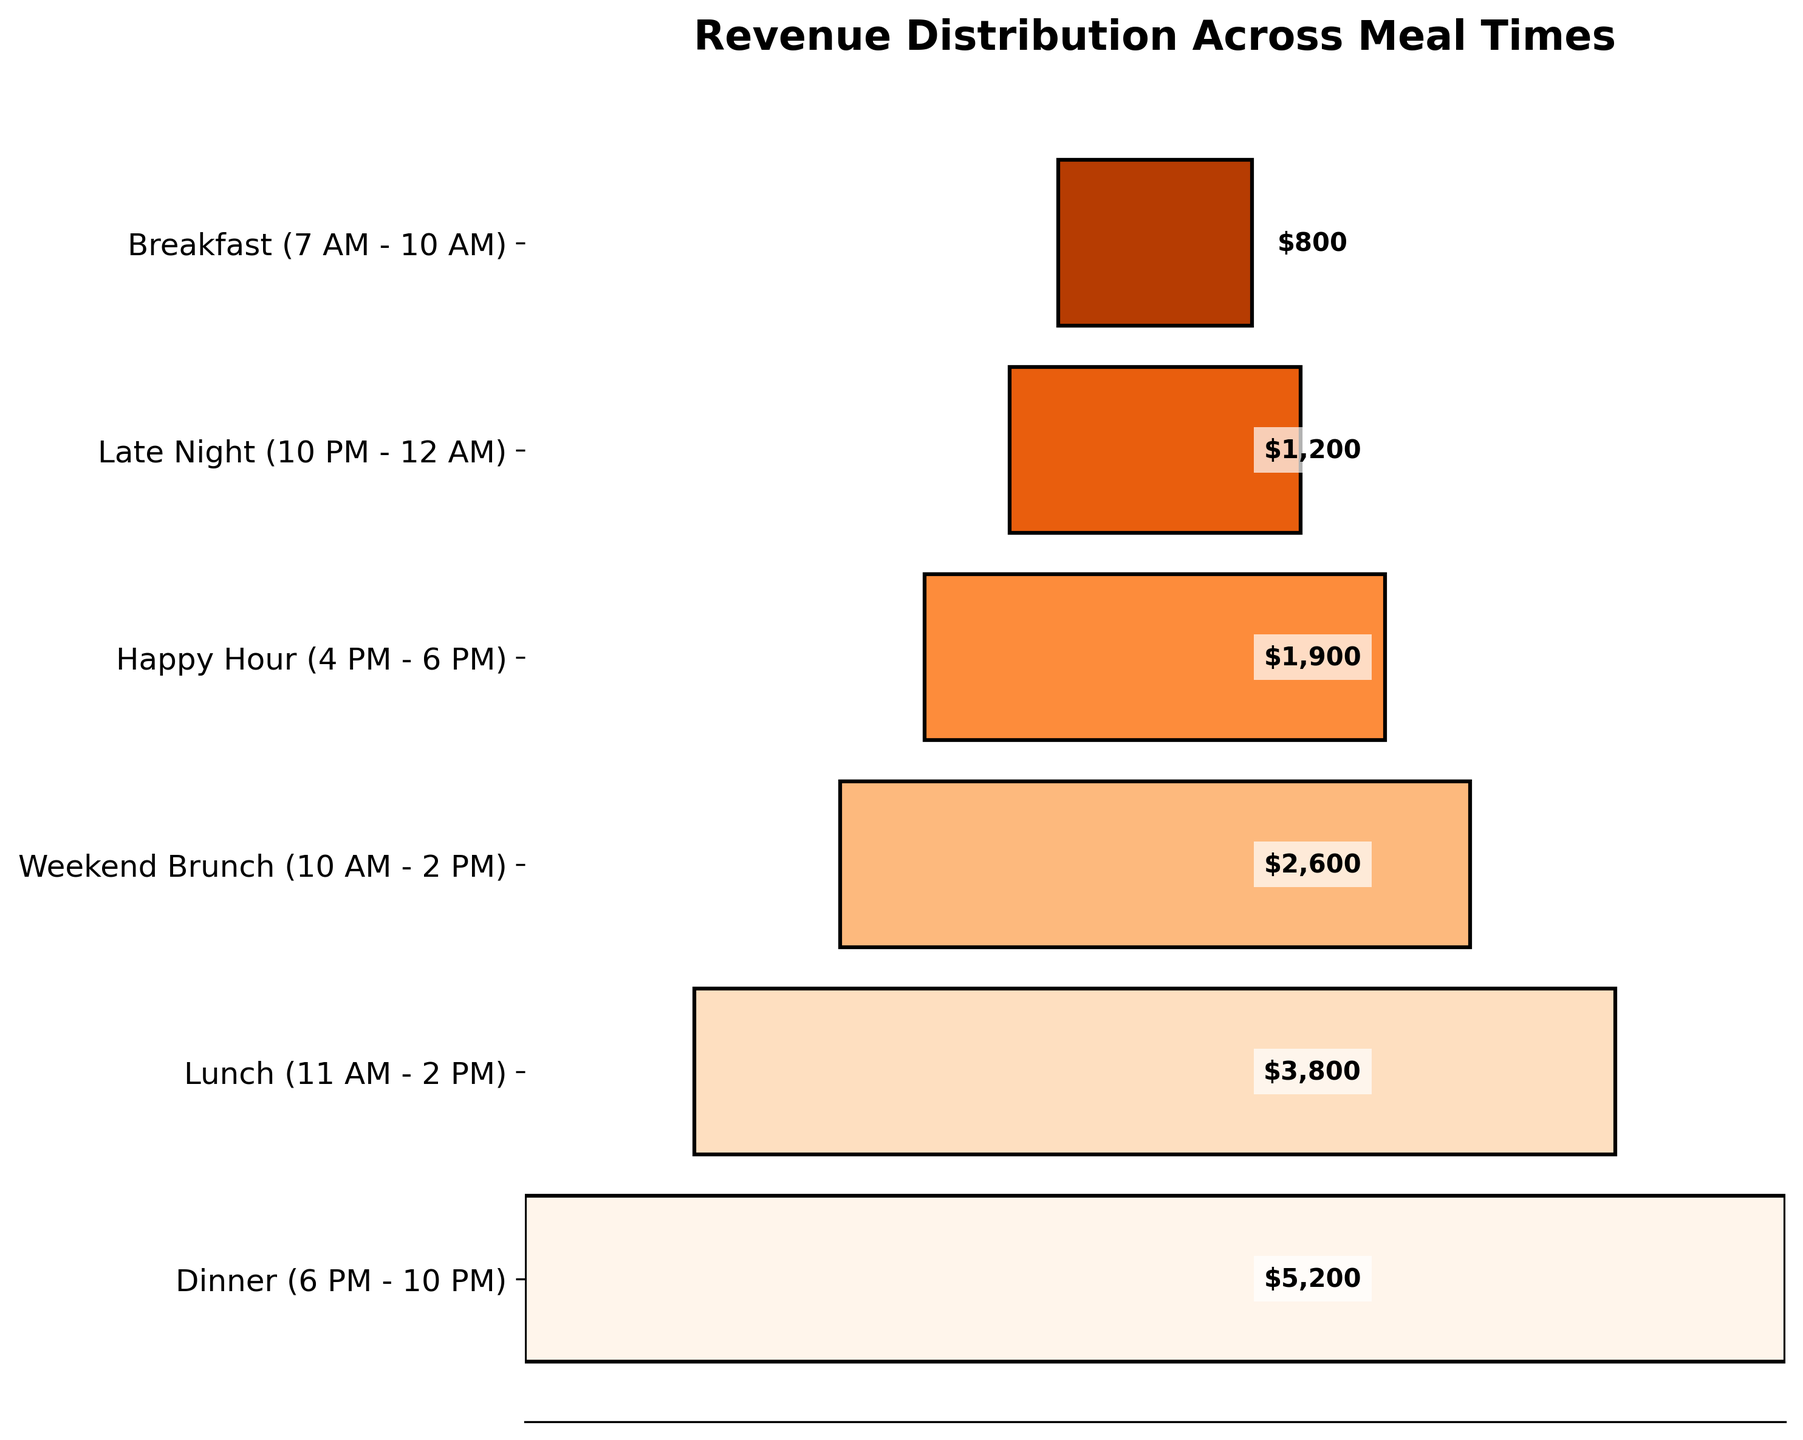what's the title of the plot? The title of the plot is displayed at the top. It reads "Revenue Distribution Across Meal Times".
Answer: Revenue Distribution Across Meal Times which meal time brings in the highest revenue? The funnel chart shows the width of the segments for each meal time. The widest segment represents the highest revenue. The "Dinner (6 PM - 10 PM)" segment is the widest.
Answer: Dinner (6 PM - 10 PM) what is the revenue during breakfast? The revenue for each meal time is indicated within the funnel segment. For Breakfast (7 AM - 10 AM), the revenue is displayed as $800.
Answer: $800 which meal time has a revenue of $2600? The revenue figures are displayed within each funnel segment. The segment with $2600 corresponds to "Weekend Brunch (10 AM - 2 PM)".
Answer: Weekend Brunch (10 AM - 2 PM) how much more revenue does lunch make compared to happy hour? Subtract the revenue of Happy Hour (4 PM - 6 PM) from the revenue of Lunch (11 AM - 2 PM). The revenues are $3800 and $1900 respectively, so the difference is $3800 - $1900 = $1900.
Answer: $1900 what is the total revenue from dinner and lunch combined? Add the revenue from Dinner (6 PM - 10 PM) and Lunch (11 AM - 2 PM). The revenues are $5200 and $3800 respectively, so the combined total is $5200 + $3800 = $9000.
Answer: $9000 which meal time has the lowest revenue? The narrowest segment in the funnel chart represents the lowest revenue. The segment "Breakfast (7 AM - 10 AM)" is the narrowest, indicating the lowest revenue.
Answer: Breakfast (7 AM - 10 AM) is brunch revenue greater than dinner revenue? Compare the widths of the segments for Weekend Brunch (10 AM - 2 PM) and Dinner (6 PM - 10 PM). The Dinner segment is wider, indicating that its revenue is higher than that of Weekend Brunch ($5200 vs. $2600).
Answer: No what is the average revenue across all meal times? First, sum all the revenues: $5200 (Dinner) + $3800 (Lunch) + $2600 (Weekend Brunch) + $1900 (Happy Hour) + $1200 (Late Night) + $800 (Breakfast) = $15500. Then divide by the number of meal times, 6. So the average is $15500 / 6 = $2583.33.
Answer: $2583.33 which meal times have a revenue less than $2000? Identify the segments with revenue figures below $2000. These segments are "Happy Hour (4 PM - 6 PM)" with $1900, "Late Night (10 PM - 12 AM)" with $1200, and "Breakfast (7 AM - 10 AM)" with $800.
Answer: Happy Hour, Late Night, Breakfast 